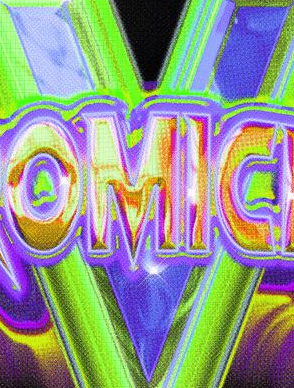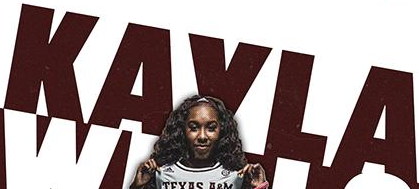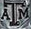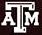What text is displayed in these images sequentially, separated by a semicolon? V; KAVLA; ATM; ATM 